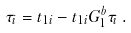Convert formula to latex. <formula><loc_0><loc_0><loc_500><loc_500>\tau _ { i } = t _ { 1 i } - t _ { 1 i } G _ { 1 } ^ { b } \tau _ { i } \, .</formula> 